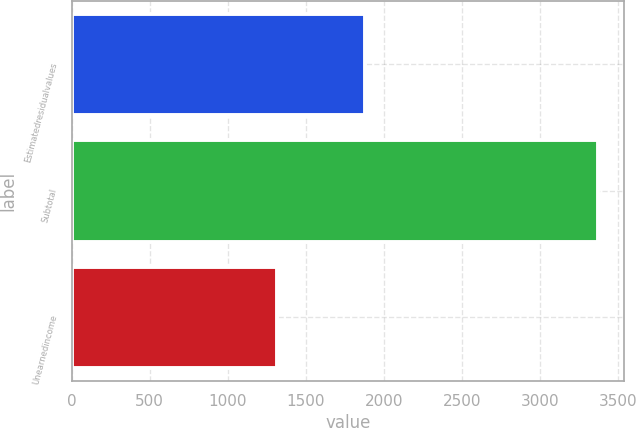Convert chart. <chart><loc_0><loc_0><loc_500><loc_500><bar_chart><fcel>Estimatedresidualvalues<fcel>Subtotal<fcel>Unearnedincome<nl><fcel>1881<fcel>3372<fcel>1313<nl></chart> 